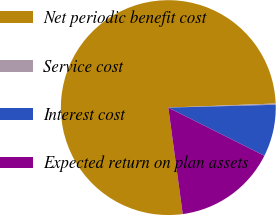Convert chart. <chart><loc_0><loc_0><loc_500><loc_500><pie_chart><fcel>Net periodic benefit cost<fcel>Service cost<fcel>Interest cost<fcel>Expected return on plan assets<nl><fcel>76.53%<fcel>0.19%<fcel>7.82%<fcel>15.46%<nl></chart> 